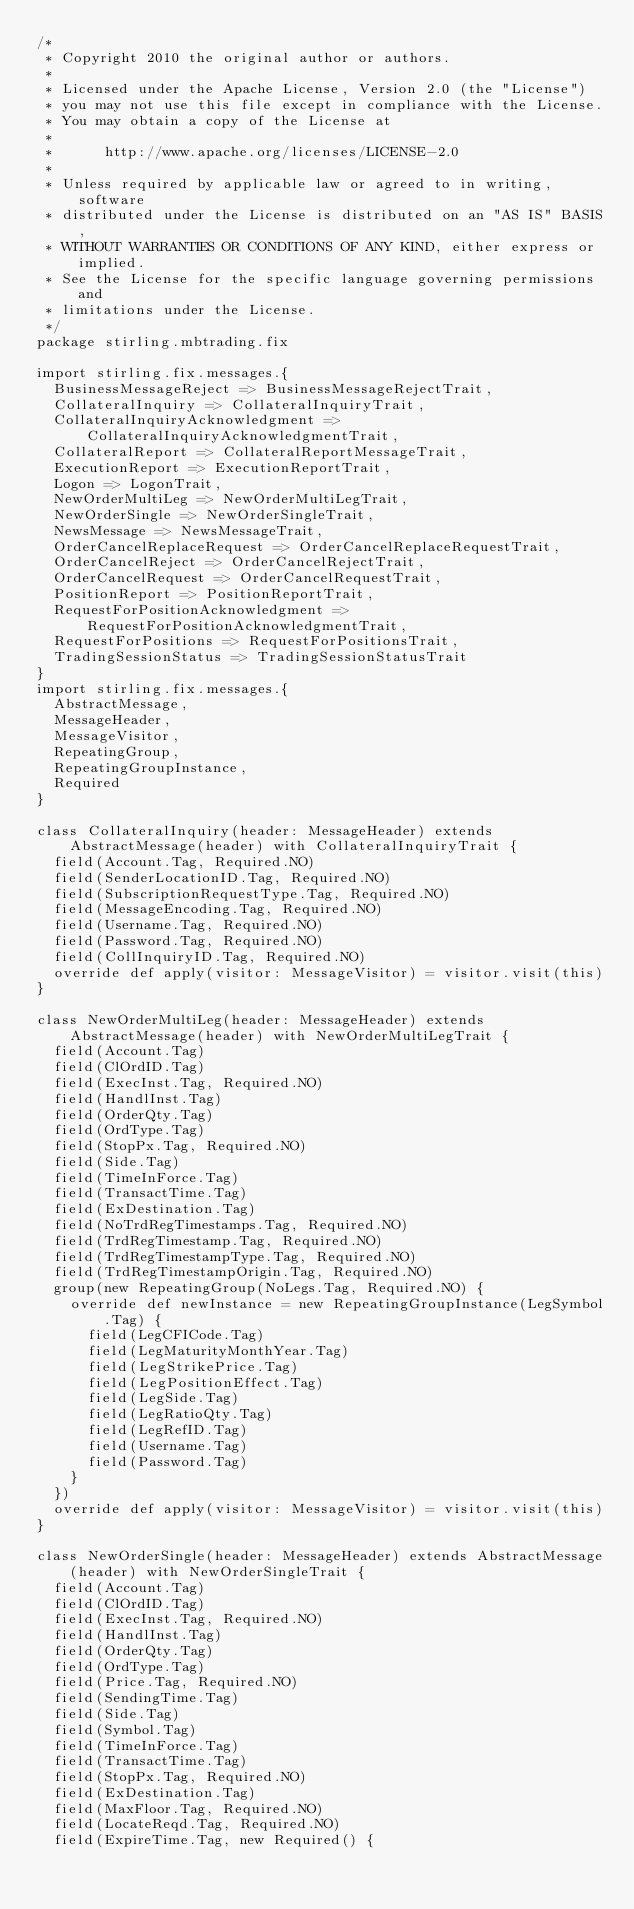<code> <loc_0><loc_0><loc_500><loc_500><_Scala_>/*
 * Copyright 2010 the original author or authors.
 *
 * Licensed under the Apache License, Version 2.0 (the "License")
 * you may not use this file except in compliance with the License.
 * You may obtain a copy of the License at
 *
 *      http://www.apache.org/licenses/LICENSE-2.0
 *
 * Unless required by applicable law or agreed to in writing, software
 * distributed under the License is distributed on an "AS IS" BASIS,
 * WITHOUT WARRANTIES OR CONDITIONS OF ANY KIND, either express or implied.
 * See the License for the specific language governing permissions and
 * limitations under the License.
 */
package stirling.mbtrading.fix

import stirling.fix.messages.{
  BusinessMessageReject => BusinessMessageRejectTrait,
  CollateralInquiry => CollateralInquiryTrait,
  CollateralInquiryAcknowledgment => CollateralInquiryAcknowledgmentTrait,
  CollateralReport => CollateralReportMessageTrait,
  ExecutionReport => ExecutionReportTrait,
  Logon => LogonTrait,
  NewOrderMultiLeg => NewOrderMultiLegTrait,
  NewOrderSingle => NewOrderSingleTrait,
  NewsMessage => NewsMessageTrait,
  OrderCancelReplaceRequest => OrderCancelReplaceRequestTrait,
  OrderCancelReject => OrderCancelRejectTrait,
  OrderCancelRequest => OrderCancelRequestTrait,
  PositionReport => PositionReportTrait,
  RequestForPositionAcknowledgment => RequestForPositionAcknowledgmentTrait,
  RequestForPositions => RequestForPositionsTrait,
  TradingSessionStatus => TradingSessionStatusTrait
}
import stirling.fix.messages.{
  AbstractMessage,
  MessageHeader,
  MessageVisitor,
  RepeatingGroup,
  RepeatingGroupInstance,
  Required
}

class CollateralInquiry(header: MessageHeader) extends AbstractMessage(header) with CollateralInquiryTrait {
  field(Account.Tag, Required.NO)
  field(SenderLocationID.Tag, Required.NO)
  field(SubscriptionRequestType.Tag, Required.NO)
  field(MessageEncoding.Tag, Required.NO)
  field(Username.Tag, Required.NO)
  field(Password.Tag, Required.NO)
  field(CollInquiryID.Tag, Required.NO)
  override def apply(visitor: MessageVisitor) = visitor.visit(this)
}

class NewOrderMultiLeg(header: MessageHeader) extends AbstractMessage(header) with NewOrderMultiLegTrait {
  field(Account.Tag)
  field(ClOrdID.Tag)
  field(ExecInst.Tag, Required.NO)
  field(HandlInst.Tag)
  field(OrderQty.Tag)
  field(OrdType.Tag)
  field(StopPx.Tag, Required.NO)
  field(Side.Tag)
  field(TimeInForce.Tag)
  field(TransactTime.Tag)
  field(ExDestination.Tag)
  field(NoTrdRegTimestamps.Tag, Required.NO)
  field(TrdRegTimestamp.Tag, Required.NO)
  field(TrdRegTimestampType.Tag, Required.NO)
  field(TrdRegTimestampOrigin.Tag, Required.NO)
  group(new RepeatingGroup(NoLegs.Tag, Required.NO) {
    override def newInstance = new RepeatingGroupInstance(LegSymbol.Tag) {
      field(LegCFICode.Tag)
      field(LegMaturityMonthYear.Tag)
      field(LegStrikePrice.Tag)
      field(LegPositionEffect.Tag)
      field(LegSide.Tag)
      field(LegRatioQty.Tag)
      field(LegRefID.Tag)
      field(Username.Tag)
      field(Password.Tag)
    }
  })
  override def apply(visitor: MessageVisitor) = visitor.visit(this)
}

class NewOrderSingle(header: MessageHeader) extends AbstractMessage(header) with NewOrderSingleTrait {
  field(Account.Tag)
  field(ClOrdID.Tag)
  field(ExecInst.Tag, Required.NO)
  field(HandlInst.Tag)
  field(OrderQty.Tag)
  field(OrdType.Tag)
  field(Price.Tag, Required.NO)
  field(SendingTime.Tag)
  field(Side.Tag)
  field(Symbol.Tag)
  field(TimeInForce.Tag)
  field(TransactTime.Tag)
  field(StopPx.Tag, Required.NO)
  field(ExDestination.Tag)
  field(MaxFloor.Tag, Required.NO)
  field(LocateReqd.Tag, Required.NO)
  field(ExpireTime.Tag, new Required() {</code> 